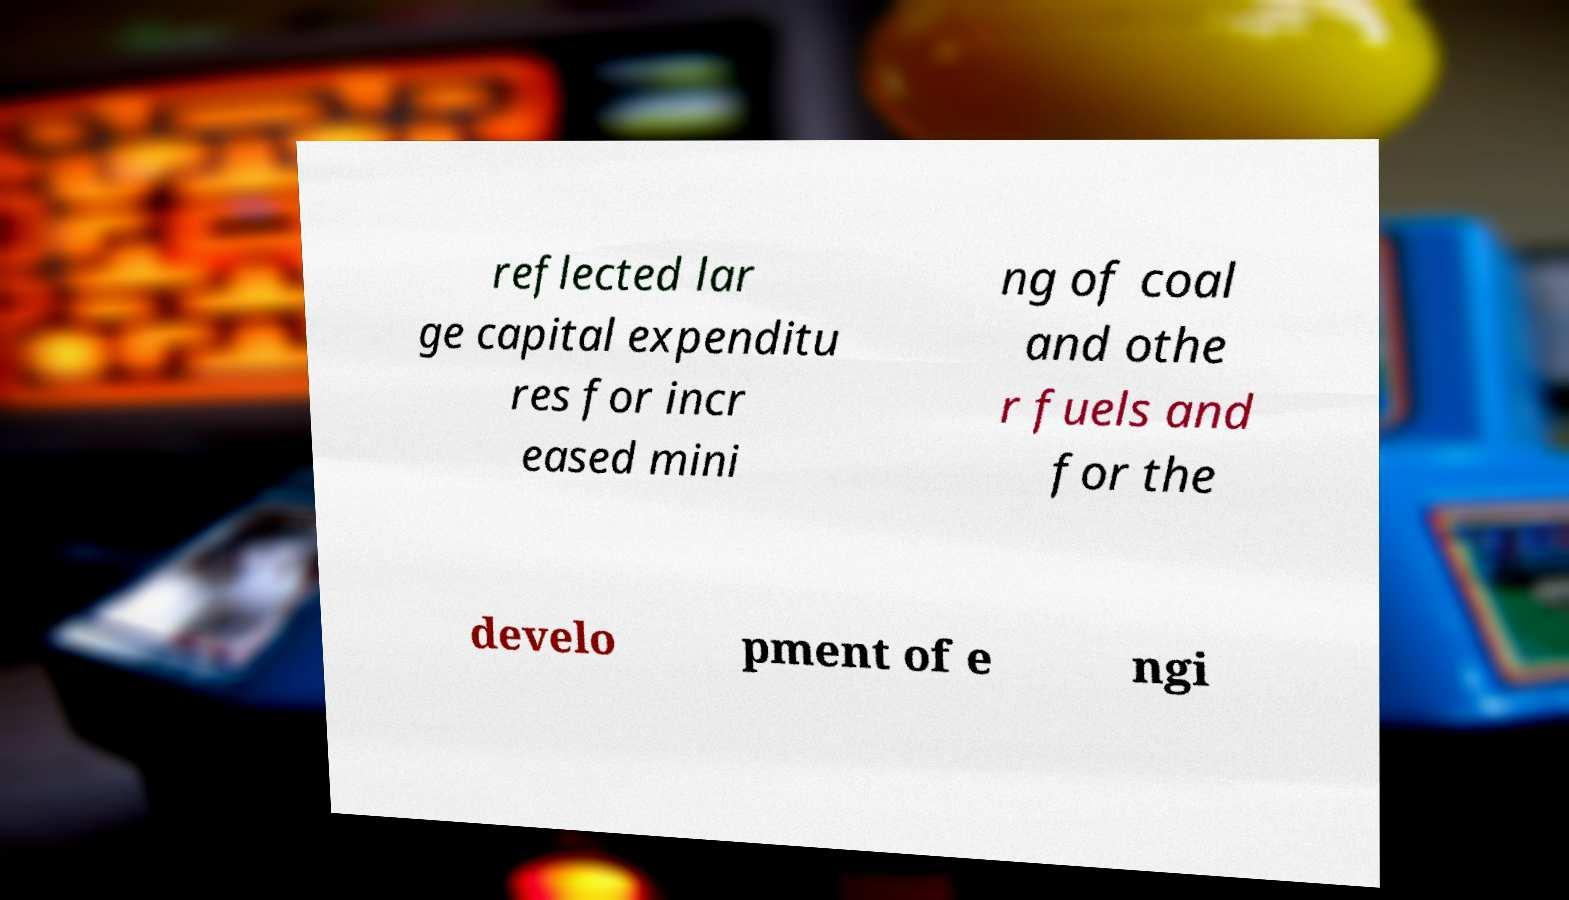Could you assist in decoding the text presented in this image and type it out clearly? reflected lar ge capital expenditu res for incr eased mini ng of coal and othe r fuels and for the develo pment of e ngi 